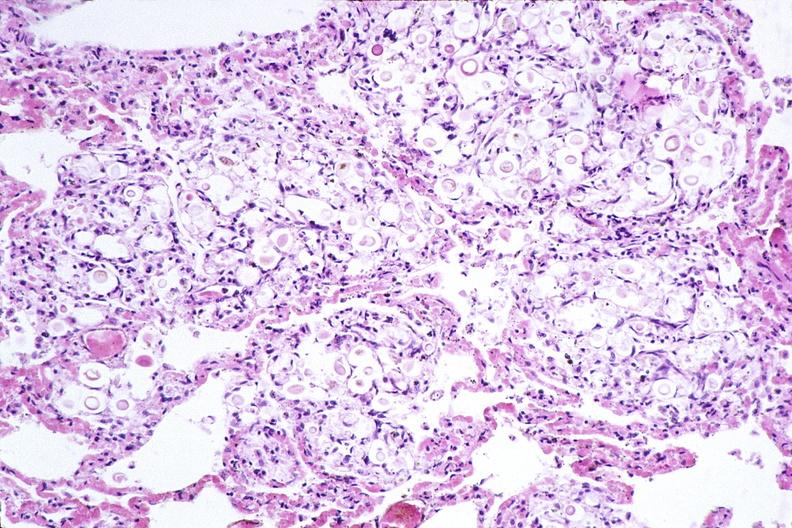does cysticercosis show lung, cryptococcal pneumonia?
Answer the question using a single word or phrase. No 